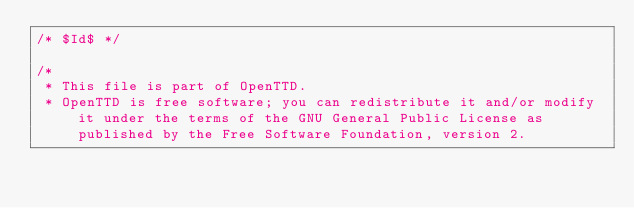Convert code to text. <code><loc_0><loc_0><loc_500><loc_500><_C_>/* $Id$ */

/*
 * This file is part of OpenTTD.
 * OpenTTD is free software; you can redistribute it and/or modify it under the terms of the GNU General Public License as published by the Free Software Foundation, version 2.</code> 